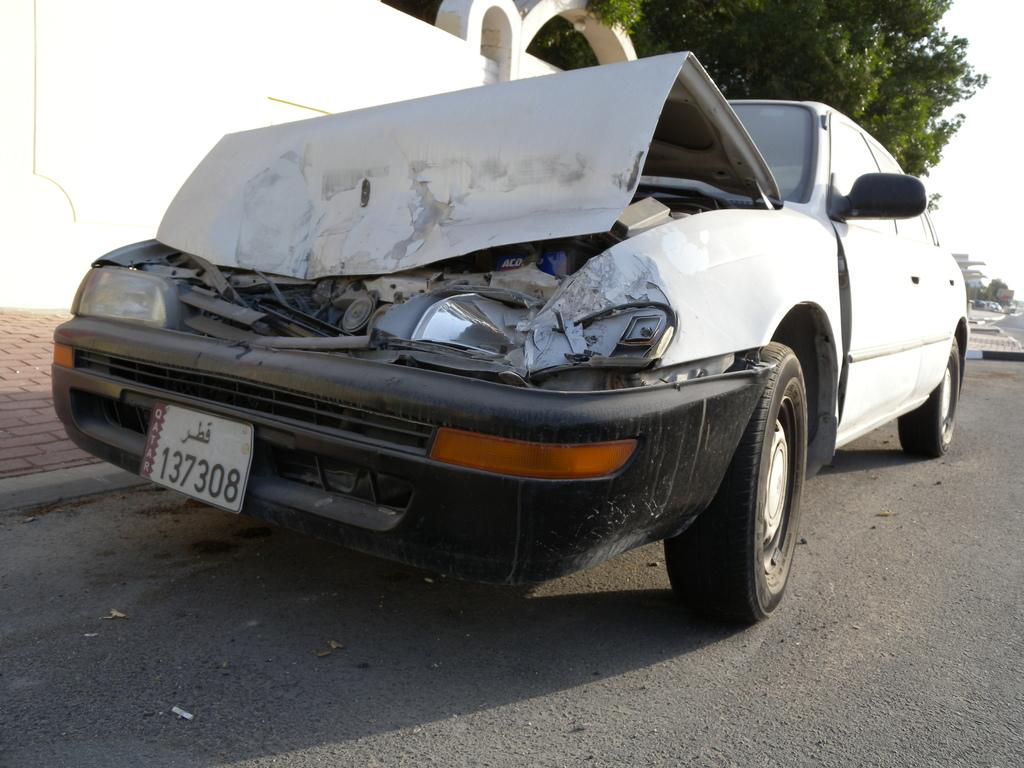<image>
Offer a succinct explanation of the picture presented. A crashed car with a license plate that displays the numbers 137308 on it. 